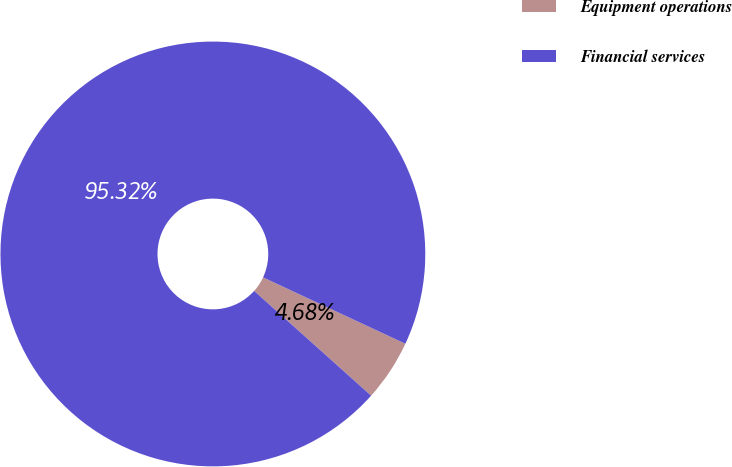Convert chart to OTSL. <chart><loc_0><loc_0><loc_500><loc_500><pie_chart><fcel>Equipment operations<fcel>Financial services<nl><fcel>4.68%<fcel>95.32%<nl></chart> 